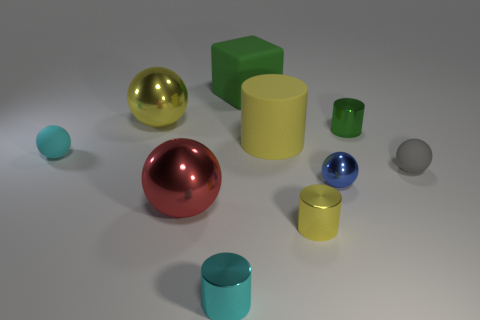Which is the largest object in the scene? The largest object appears to be the yellow cylinder positioned towards the center of the image. Could you describe its texture or finish? The yellow cylinder has a matte finish and smooth texture, which distinguishes it from the shiny spheres. 